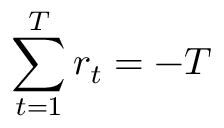Convert formula to latex. <formula><loc_0><loc_0><loc_500><loc_500>\sum _ { t = 1 } ^ { T } r _ { t } = - T</formula> 